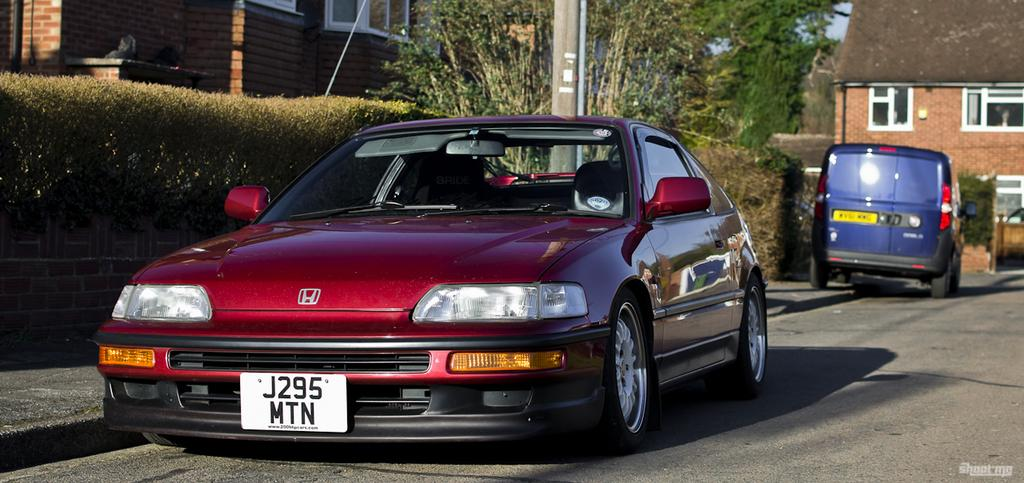What can be seen on the road in the image? There are vehicles on the road in the image. What is visible in the background of the image? In the background of the image, there are trees, buildings, a pole, plants, a pavement, and a boundary wall. Can you describe the surroundings of the road in the image? The surroundings of the road include trees, buildings, a pole, plants, a pavement, and a boundary wall. What type of statement can be seen written on the bedroom wall in the image? There is no bedroom or statement written on a wall present in the image. 